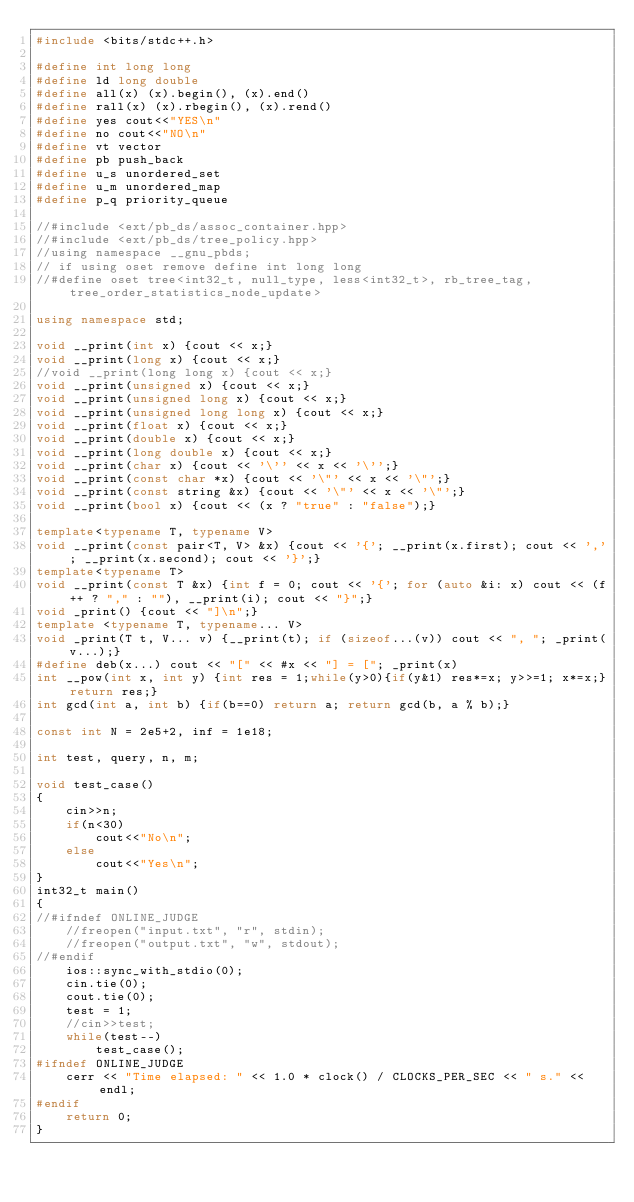<code> <loc_0><loc_0><loc_500><loc_500><_C++_>#include <bits/stdc++.h>

#define int long long
#define ld long double
#define all(x) (x).begin(), (x).end()
#define rall(x) (x).rbegin(), (x).rend()
#define yes cout<<"YES\n"
#define no cout<<"NO\n"
#define vt vector
#define pb push_back
#define u_s unordered_set
#define u_m unordered_map
#define p_q priority_queue

//#include <ext/pb_ds/assoc_container.hpp>
//#include <ext/pb_ds/tree_policy.hpp>
//using namespace __gnu_pbds;
// if using oset remove define int long long
//#define oset tree<int32_t, null_type, less<int32_t>, rb_tree_tag, tree_order_statistics_node_update>

using namespace std;

void __print(int x) {cout << x;}
void __print(long x) {cout << x;}
//void __print(long long x) {cout << x;}
void __print(unsigned x) {cout << x;}
void __print(unsigned long x) {cout << x;}
void __print(unsigned long long x) {cout << x;}
void __print(float x) {cout << x;}
void __print(double x) {cout << x;}
void __print(long double x) {cout << x;}
void __print(char x) {cout << '\'' << x << '\'';}
void __print(const char *x) {cout << '\"' << x << '\"';}
void __print(const string &x) {cout << '\"' << x << '\"';}
void __print(bool x) {cout << (x ? "true" : "false");}

template<typename T, typename V>
void __print(const pair<T, V> &x) {cout << '{'; __print(x.first); cout << ','; __print(x.second); cout << '}';}
template<typename T>
void __print(const T &x) {int f = 0; cout << '{'; for (auto &i: x) cout << (f++ ? "," : ""), __print(i); cout << "}";}
void _print() {cout << "]\n";}
template <typename T, typename... V>
void _print(T t, V... v) {__print(t); if (sizeof...(v)) cout << ", "; _print(v...);}
#define deb(x...) cout << "[" << #x << "] = ["; _print(x)
int __pow(int x, int y) {int res = 1;while(y>0){if(y&1) res*=x; y>>=1; x*=x;}return res;}
int gcd(int a, int b) {if(b==0) return a; return gcd(b, a % b);}

const int N = 2e5+2, inf = 1e18;

int test, query, n, m;

void test_case()
{
    cin>>n;
    if(n<30)
        cout<<"No\n";
    else
        cout<<"Yes\n";
}
int32_t main()
{
//#ifndef ONLINE_JUDGE
	//freopen("input.txt", "r", stdin);
	//freopen("output.txt", "w", stdout);
//#endif
    ios::sync_with_stdio(0);
    cin.tie(0);
    cout.tie(0);
    test = 1;
    //cin>>test;
    while(test--)
        test_case();
#ifndef ONLINE_JUDGE
    cerr << "Time elapsed: " << 1.0 * clock() / CLOCKS_PER_SEC << " s." << endl;
#endif
    return 0;
}
</code> 